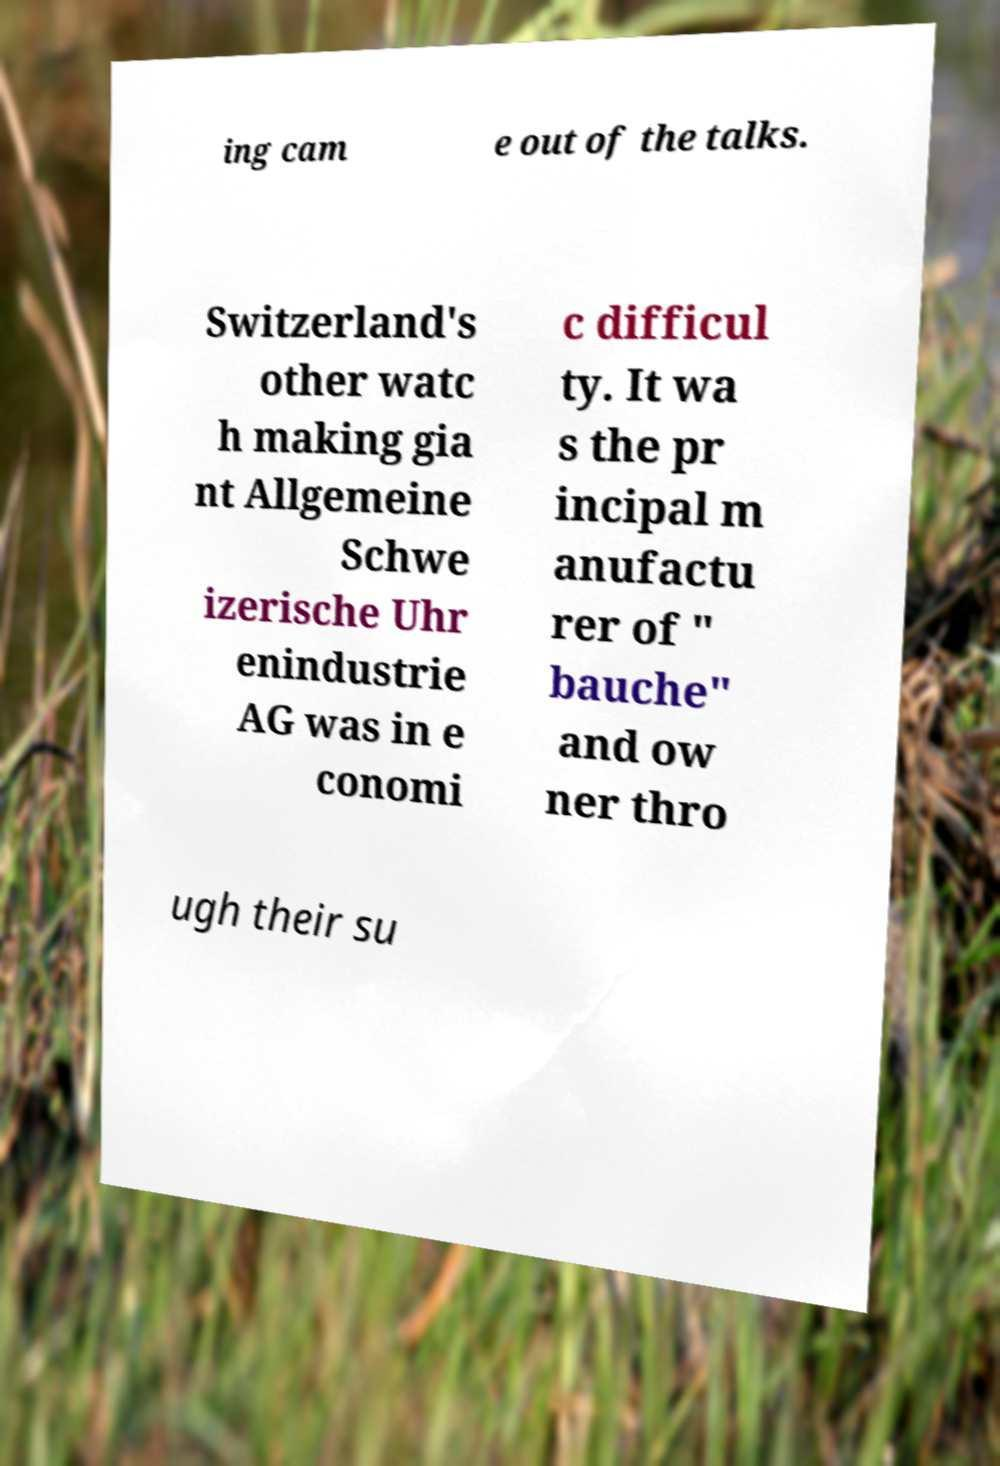Can you read and provide the text displayed in the image?This photo seems to have some interesting text. Can you extract and type it out for me? ing cam e out of the talks. Switzerland's other watc h making gia nt Allgemeine Schwe izerische Uhr enindustrie AG was in e conomi c difficul ty. It wa s the pr incipal m anufactu rer of " bauche" and ow ner thro ugh their su 